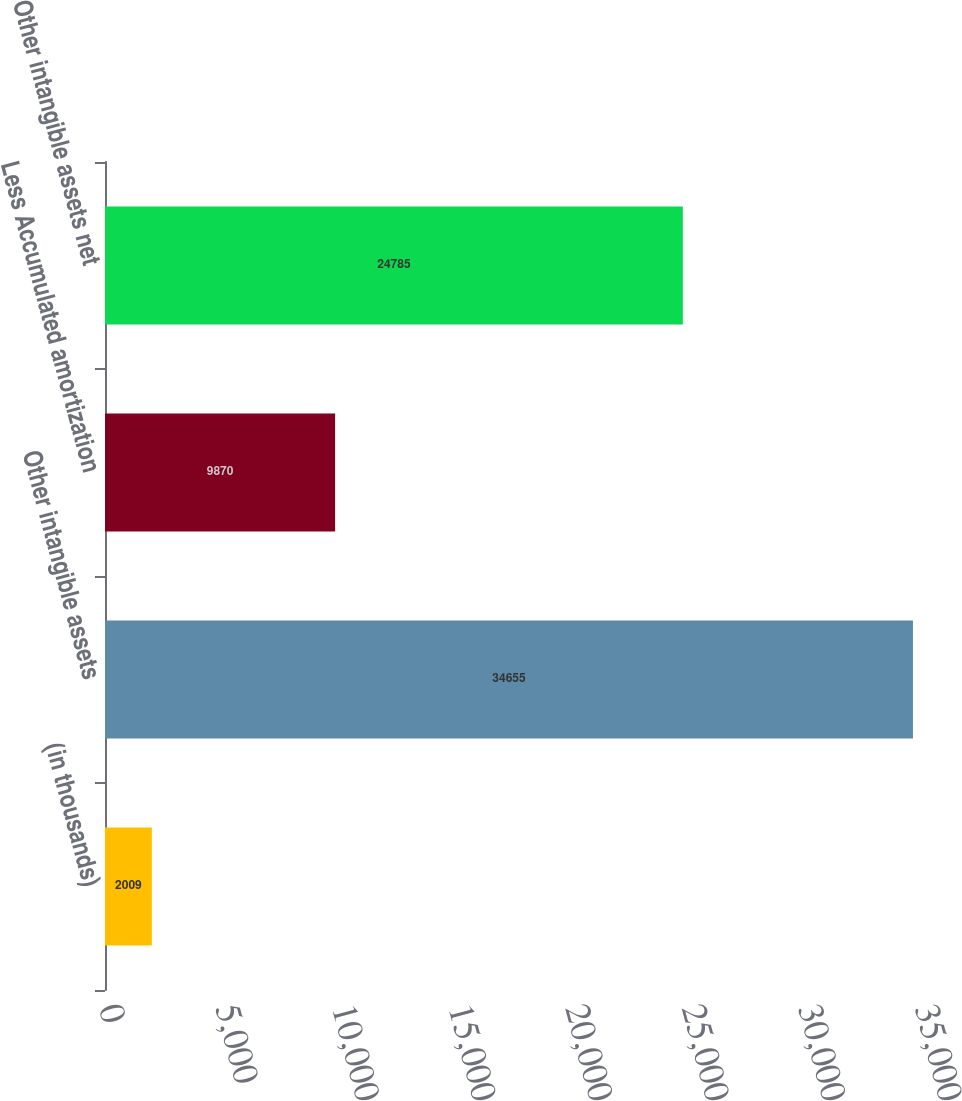Convert chart. <chart><loc_0><loc_0><loc_500><loc_500><bar_chart><fcel>(in thousands)<fcel>Other intangible assets<fcel>Less Accumulated amortization<fcel>Other intangible assets net<nl><fcel>2009<fcel>34655<fcel>9870<fcel>24785<nl></chart> 